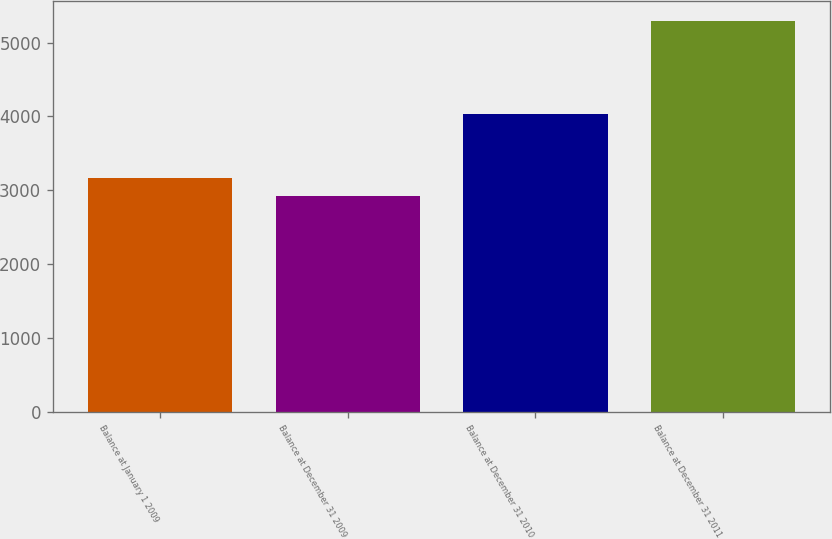Convert chart. <chart><loc_0><loc_0><loc_500><loc_500><bar_chart><fcel>Balance at January 1 2009<fcel>Balance at December 31 2009<fcel>Balance at December 31 2010<fcel>Balance at December 31 2011<nl><fcel>3160.9<fcel>2924<fcel>4027<fcel>5293<nl></chart> 